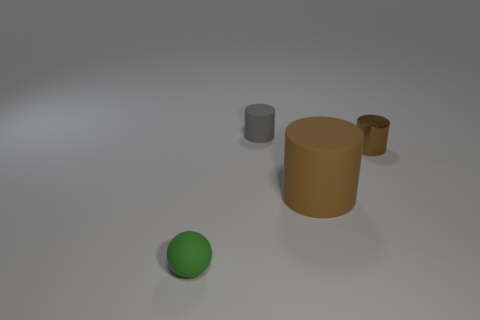Subtract all big rubber cylinders. How many cylinders are left? 2 Subtract all brown cylinders. How many cylinders are left? 1 Subtract all balls. How many objects are left? 3 Add 4 tiny green matte spheres. How many objects exist? 8 Subtract all brown balls. How many brown cylinders are left? 2 Subtract all balls. Subtract all brown shiny things. How many objects are left? 2 Add 4 brown cylinders. How many brown cylinders are left? 6 Add 2 yellow blocks. How many yellow blocks exist? 2 Subtract 2 brown cylinders. How many objects are left? 2 Subtract all yellow cylinders. Subtract all purple blocks. How many cylinders are left? 3 